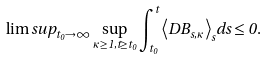Convert formula to latex. <formula><loc_0><loc_0><loc_500><loc_500>\lim s u p _ { t _ { 0 } \rightarrow \infty } \sup _ { \kappa \geq 1 , t \geq t _ { 0 } } \int _ { t _ { 0 } } ^ { t } { \left \langle D B _ { s , \kappa } \right \rangle } _ { s } d s \leq 0 .</formula> 